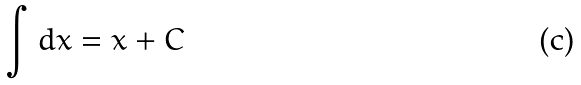Convert formula to latex. <formula><loc_0><loc_0><loc_500><loc_500>\int d x = x + C</formula> 